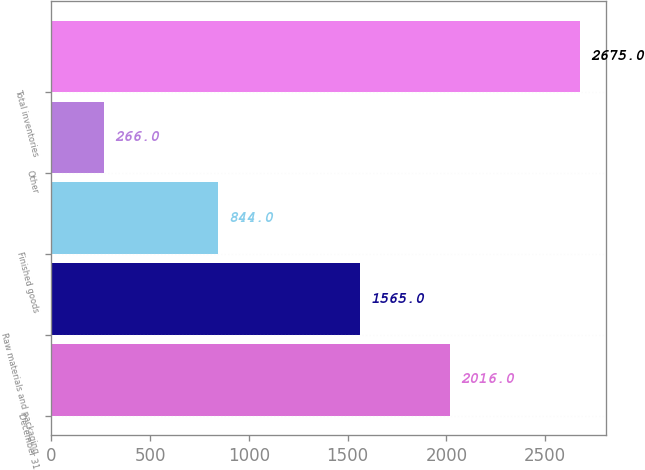<chart> <loc_0><loc_0><loc_500><loc_500><bar_chart><fcel>December 31<fcel>Raw materials and packaging<fcel>Finished goods<fcel>Other<fcel>Total inventories<nl><fcel>2016<fcel>1565<fcel>844<fcel>266<fcel>2675<nl></chart> 